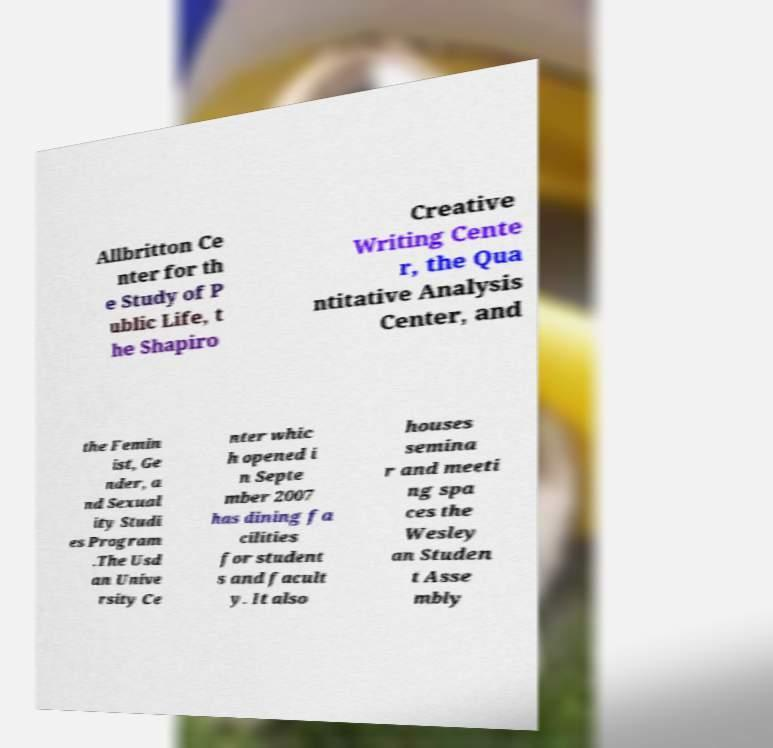What messages or text are displayed in this image? I need them in a readable, typed format. Allbritton Ce nter for th e Study of P ublic Life, t he Shapiro Creative Writing Cente r, the Qua ntitative Analysis Center, and the Femin ist, Ge nder, a nd Sexual ity Studi es Program .The Usd an Unive rsity Ce nter whic h opened i n Septe mber 2007 has dining fa cilities for student s and facult y. It also houses semina r and meeti ng spa ces the Wesley an Studen t Asse mbly 